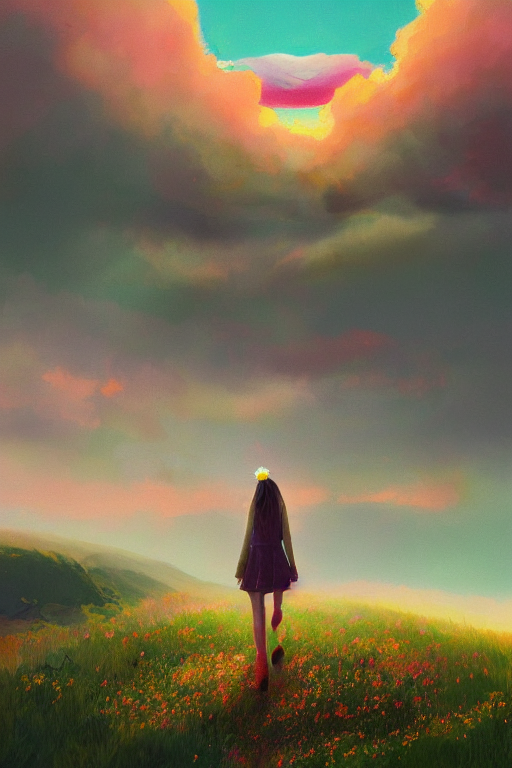Could you suggest a story or a theme that this image might be representing? The image might represent a theme of journey and personal growth. The figure's path leading towards the horizon can symbolize the journey through life, with the vibrant colors representing key moments of joy, wonder, and self-discovery. Additionally, the opening in the clouds could symbolize an epiphany or a newfound clarity, highlighting transformative experiences. 